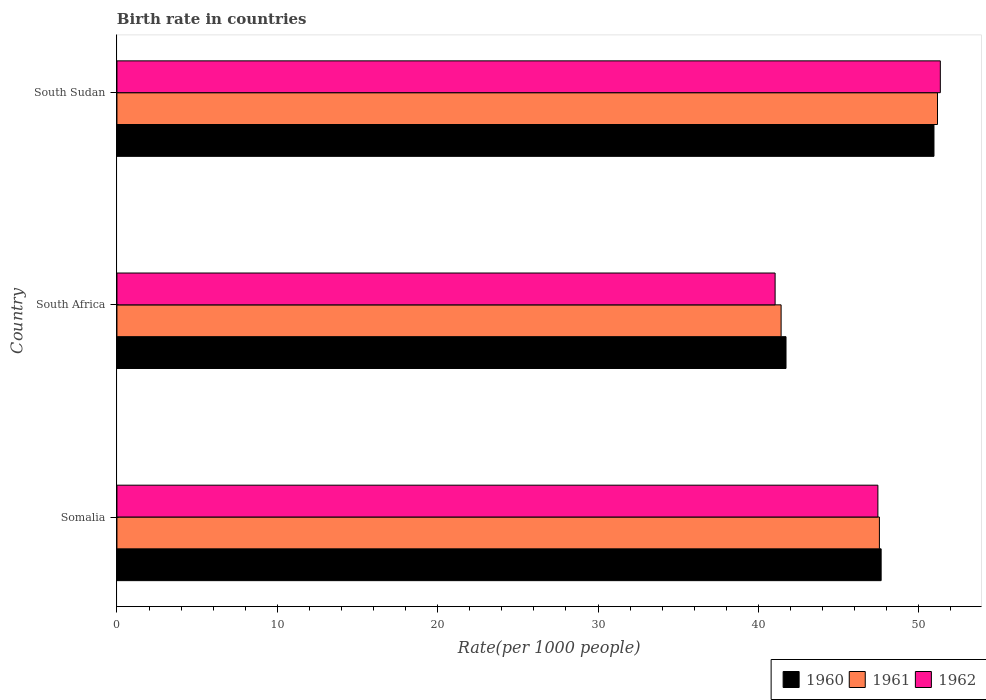How many different coloured bars are there?
Make the answer very short. 3. Are the number of bars per tick equal to the number of legend labels?
Keep it short and to the point. Yes. Are the number of bars on each tick of the Y-axis equal?
Your answer should be very brief. Yes. How many bars are there on the 3rd tick from the top?
Give a very brief answer. 3. How many bars are there on the 1st tick from the bottom?
Give a very brief answer. 3. What is the label of the 1st group of bars from the top?
Ensure brevity in your answer.  South Sudan. In how many cases, is the number of bars for a given country not equal to the number of legend labels?
Your response must be concise. 0. What is the birth rate in 1960 in South Sudan?
Ensure brevity in your answer.  50.95. Across all countries, what is the maximum birth rate in 1962?
Provide a succinct answer. 51.34. Across all countries, what is the minimum birth rate in 1962?
Offer a terse response. 41.04. In which country was the birth rate in 1960 maximum?
Provide a short and direct response. South Sudan. In which country was the birth rate in 1960 minimum?
Your response must be concise. South Africa. What is the total birth rate in 1961 in the graph?
Keep it short and to the point. 140.12. What is the difference between the birth rate in 1962 in Somalia and that in South Africa?
Provide a short and direct response. 6.41. What is the difference between the birth rate in 1960 in South Africa and the birth rate in 1962 in Somalia?
Offer a very short reply. -5.73. What is the average birth rate in 1961 per country?
Your answer should be compact. 46.71. What is the difference between the birth rate in 1960 and birth rate in 1961 in South Sudan?
Provide a succinct answer. -0.22. What is the ratio of the birth rate in 1960 in Somalia to that in South Africa?
Make the answer very short. 1.14. Is the birth rate in 1961 in Somalia less than that in South Sudan?
Ensure brevity in your answer.  Yes. What is the difference between the highest and the second highest birth rate in 1962?
Your answer should be very brief. 3.89. What is the difference between the highest and the lowest birth rate in 1962?
Your response must be concise. 10.3. Is the sum of the birth rate in 1962 in Somalia and South Sudan greater than the maximum birth rate in 1961 across all countries?
Ensure brevity in your answer.  Yes. Are the values on the major ticks of X-axis written in scientific E-notation?
Keep it short and to the point. No. Does the graph contain any zero values?
Ensure brevity in your answer.  No. What is the title of the graph?
Your answer should be compact. Birth rate in countries. Does "1984" appear as one of the legend labels in the graph?
Offer a very short reply. No. What is the label or title of the X-axis?
Offer a very short reply. Rate(per 1000 people). What is the Rate(per 1000 people) in 1960 in Somalia?
Give a very brief answer. 47.65. What is the Rate(per 1000 people) in 1961 in Somalia?
Make the answer very short. 47.54. What is the Rate(per 1000 people) of 1962 in Somalia?
Your response must be concise. 47.45. What is the Rate(per 1000 people) of 1960 in South Africa?
Your response must be concise. 41.72. What is the Rate(per 1000 people) of 1961 in South Africa?
Provide a short and direct response. 41.41. What is the Rate(per 1000 people) of 1962 in South Africa?
Offer a very short reply. 41.04. What is the Rate(per 1000 people) of 1960 in South Sudan?
Keep it short and to the point. 50.95. What is the Rate(per 1000 people) of 1961 in South Sudan?
Make the answer very short. 51.16. What is the Rate(per 1000 people) in 1962 in South Sudan?
Keep it short and to the point. 51.34. Across all countries, what is the maximum Rate(per 1000 people) of 1960?
Your answer should be compact. 50.95. Across all countries, what is the maximum Rate(per 1000 people) in 1961?
Your answer should be very brief. 51.16. Across all countries, what is the maximum Rate(per 1000 people) of 1962?
Your answer should be very brief. 51.34. Across all countries, what is the minimum Rate(per 1000 people) of 1960?
Offer a terse response. 41.72. Across all countries, what is the minimum Rate(per 1000 people) in 1961?
Offer a terse response. 41.41. Across all countries, what is the minimum Rate(per 1000 people) in 1962?
Keep it short and to the point. 41.04. What is the total Rate(per 1000 people) of 1960 in the graph?
Give a very brief answer. 140.31. What is the total Rate(per 1000 people) in 1961 in the graph?
Offer a very short reply. 140.12. What is the total Rate(per 1000 people) in 1962 in the graph?
Your answer should be very brief. 139.83. What is the difference between the Rate(per 1000 people) in 1960 in Somalia and that in South Africa?
Your answer should be very brief. 5.93. What is the difference between the Rate(per 1000 people) of 1961 in Somalia and that in South Africa?
Provide a short and direct response. 6.13. What is the difference between the Rate(per 1000 people) in 1962 in Somalia and that in South Africa?
Your answer should be compact. 6.41. What is the difference between the Rate(per 1000 people) in 1960 in Somalia and that in South Sudan?
Offer a very short reply. -3.29. What is the difference between the Rate(per 1000 people) in 1961 in Somalia and that in South Sudan?
Provide a short and direct response. -3.62. What is the difference between the Rate(per 1000 people) of 1962 in Somalia and that in South Sudan?
Your answer should be very brief. -3.89. What is the difference between the Rate(per 1000 people) of 1960 in South Africa and that in South Sudan?
Provide a succinct answer. -9.23. What is the difference between the Rate(per 1000 people) in 1961 in South Africa and that in South Sudan?
Make the answer very short. -9.75. What is the difference between the Rate(per 1000 people) in 1962 in South Africa and that in South Sudan?
Ensure brevity in your answer.  -10.3. What is the difference between the Rate(per 1000 people) in 1960 in Somalia and the Rate(per 1000 people) in 1961 in South Africa?
Your response must be concise. 6.24. What is the difference between the Rate(per 1000 people) in 1960 in Somalia and the Rate(per 1000 people) in 1962 in South Africa?
Provide a short and direct response. 6.61. What is the difference between the Rate(per 1000 people) in 1961 in Somalia and the Rate(per 1000 people) in 1962 in South Africa?
Provide a succinct answer. 6.5. What is the difference between the Rate(per 1000 people) of 1960 in Somalia and the Rate(per 1000 people) of 1961 in South Sudan?
Your answer should be very brief. -3.51. What is the difference between the Rate(per 1000 people) in 1960 in Somalia and the Rate(per 1000 people) in 1962 in South Sudan?
Your answer should be very brief. -3.69. What is the difference between the Rate(per 1000 people) of 1961 in Somalia and the Rate(per 1000 people) of 1962 in South Sudan?
Provide a succinct answer. -3.8. What is the difference between the Rate(per 1000 people) of 1960 in South Africa and the Rate(per 1000 people) of 1961 in South Sudan?
Your answer should be very brief. -9.45. What is the difference between the Rate(per 1000 people) in 1960 in South Africa and the Rate(per 1000 people) in 1962 in South Sudan?
Ensure brevity in your answer.  -9.62. What is the difference between the Rate(per 1000 people) of 1961 in South Africa and the Rate(per 1000 people) of 1962 in South Sudan?
Make the answer very short. -9.93. What is the average Rate(per 1000 people) in 1960 per country?
Keep it short and to the point. 46.77. What is the average Rate(per 1000 people) in 1961 per country?
Ensure brevity in your answer.  46.71. What is the average Rate(per 1000 people) of 1962 per country?
Offer a very short reply. 46.61. What is the difference between the Rate(per 1000 people) of 1960 and Rate(per 1000 people) of 1961 in Somalia?
Offer a terse response. 0.11. What is the difference between the Rate(per 1000 people) of 1960 and Rate(per 1000 people) of 1962 in Somalia?
Make the answer very short. 0.2. What is the difference between the Rate(per 1000 people) of 1961 and Rate(per 1000 people) of 1962 in Somalia?
Your answer should be very brief. 0.1. What is the difference between the Rate(per 1000 people) in 1960 and Rate(per 1000 people) in 1961 in South Africa?
Your answer should be very brief. 0.31. What is the difference between the Rate(per 1000 people) in 1960 and Rate(per 1000 people) in 1962 in South Africa?
Keep it short and to the point. 0.68. What is the difference between the Rate(per 1000 people) of 1961 and Rate(per 1000 people) of 1962 in South Africa?
Offer a very short reply. 0.37. What is the difference between the Rate(per 1000 people) in 1960 and Rate(per 1000 people) in 1961 in South Sudan?
Make the answer very short. -0.22. What is the difference between the Rate(per 1000 people) of 1960 and Rate(per 1000 people) of 1962 in South Sudan?
Keep it short and to the point. -0.4. What is the difference between the Rate(per 1000 people) in 1961 and Rate(per 1000 people) in 1962 in South Sudan?
Your answer should be very brief. -0.18. What is the ratio of the Rate(per 1000 people) of 1960 in Somalia to that in South Africa?
Give a very brief answer. 1.14. What is the ratio of the Rate(per 1000 people) in 1961 in Somalia to that in South Africa?
Offer a very short reply. 1.15. What is the ratio of the Rate(per 1000 people) of 1962 in Somalia to that in South Africa?
Provide a short and direct response. 1.16. What is the ratio of the Rate(per 1000 people) of 1960 in Somalia to that in South Sudan?
Provide a short and direct response. 0.94. What is the ratio of the Rate(per 1000 people) of 1961 in Somalia to that in South Sudan?
Your response must be concise. 0.93. What is the ratio of the Rate(per 1000 people) of 1962 in Somalia to that in South Sudan?
Ensure brevity in your answer.  0.92. What is the ratio of the Rate(per 1000 people) in 1960 in South Africa to that in South Sudan?
Make the answer very short. 0.82. What is the ratio of the Rate(per 1000 people) in 1961 in South Africa to that in South Sudan?
Keep it short and to the point. 0.81. What is the ratio of the Rate(per 1000 people) in 1962 in South Africa to that in South Sudan?
Keep it short and to the point. 0.8. What is the difference between the highest and the second highest Rate(per 1000 people) in 1960?
Ensure brevity in your answer.  3.29. What is the difference between the highest and the second highest Rate(per 1000 people) of 1961?
Offer a terse response. 3.62. What is the difference between the highest and the second highest Rate(per 1000 people) in 1962?
Offer a terse response. 3.89. What is the difference between the highest and the lowest Rate(per 1000 people) of 1960?
Provide a short and direct response. 9.23. What is the difference between the highest and the lowest Rate(per 1000 people) in 1961?
Keep it short and to the point. 9.75. What is the difference between the highest and the lowest Rate(per 1000 people) in 1962?
Your answer should be very brief. 10.3. 